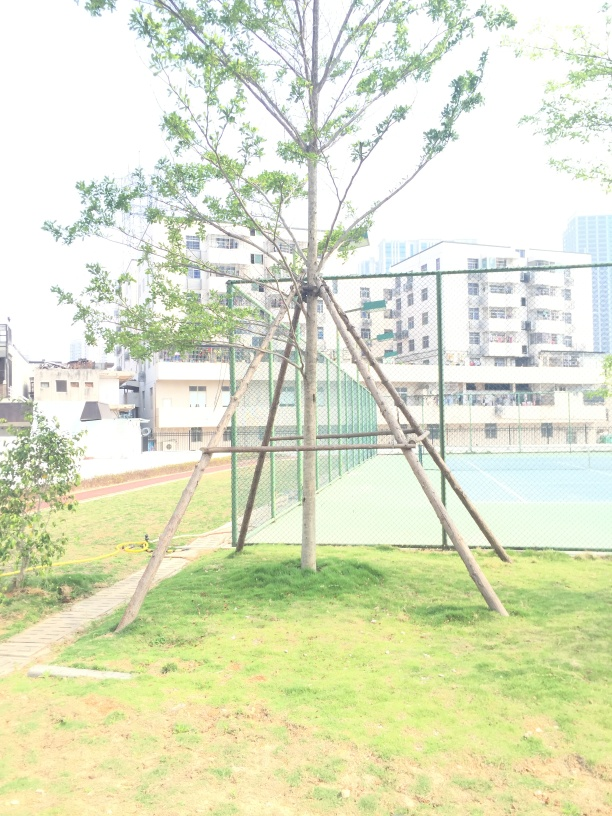What can you infer about the location shown in the image? The photo depicts an urban park setting with a tree supported by stakes, a grassy area, a paved path, and what appears to be a tennis court in the background. This suggests the location is a community recreational area within a city or residential district. Is there anything that might indicate the country or region where this park is located? Without distinct landmarks or cultural indicators, it is challenging to determine the exact country or region. However, the architectural style of the buildings in the background and the design of the park might suggest an East Asian country, but this is purely speculative. 